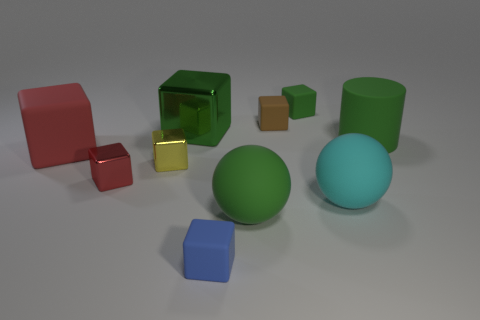Are there any cyan matte spheres of the same size as the brown matte cube?
Offer a terse response. No. How big is the matte sphere that is in front of the cyan rubber sphere?
Ensure brevity in your answer.  Large. Is there a green cube in front of the tiny thing on the right side of the tiny brown block?
Your answer should be compact. Yes. How many other objects are the same shape as the large cyan rubber object?
Your answer should be compact. 1. Does the blue rubber thing have the same shape as the tiny green thing?
Your response must be concise. Yes. There is a thing that is in front of the big rubber cube and left of the small yellow block; what is its color?
Make the answer very short. Red. There is a metal block that is the same color as the cylinder; what is its size?
Make the answer very short. Large. What number of big objects are either red matte cubes or blue metallic objects?
Provide a short and direct response. 1. Is there any other thing that is the same color as the big matte cylinder?
Give a very brief answer. Yes. There is a tiny cube that is in front of the large rubber sphere behind the big matte sphere that is on the left side of the tiny brown rubber cube; what is it made of?
Your answer should be very brief. Rubber. 